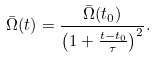Convert formula to latex. <formula><loc_0><loc_0><loc_500><loc_500>\bar { \Omega } ( t ) = \frac { \bar { \Omega } ( t _ { 0 } ) } { \left ( 1 + \frac { t - t _ { 0 } } { \tau } \right ) ^ { 2 } } .</formula> 